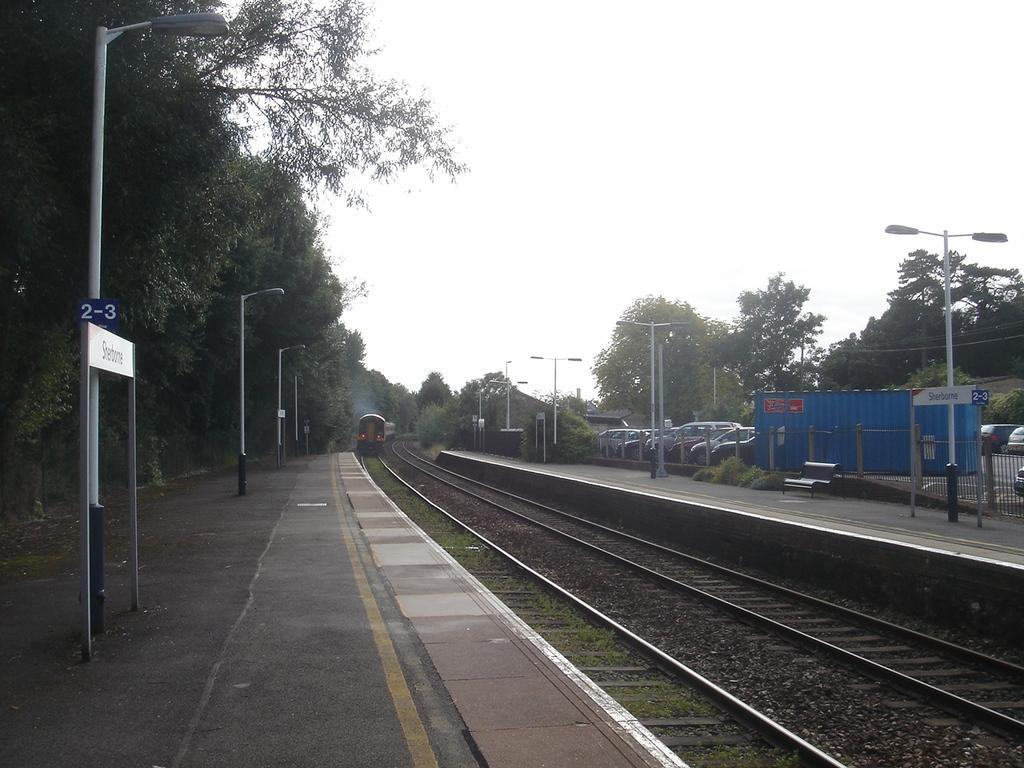Could you give a brief overview of what you see in this image? In this picture we can see the railway track, one train is moving and beside we can see some trees and electric poles. 